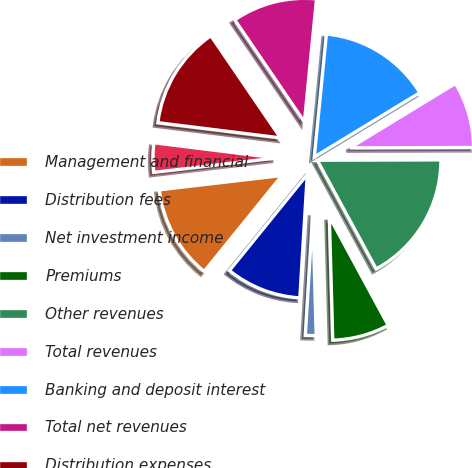Convert chart. <chart><loc_0><loc_0><loc_500><loc_500><pie_chart><fcel>Management and financial<fcel>Distribution fees<fcel>Net investment income<fcel>Premiums<fcel>Other revenues<fcel>Total revenues<fcel>Banking and deposit interest<fcel>Total net revenues<fcel>Distribution expenses<fcel>Interest credited to fixed<nl><fcel>12.3%<fcel>9.88%<fcel>1.4%<fcel>7.46%<fcel>17.14%<fcel>8.67%<fcel>14.72%<fcel>11.09%<fcel>13.51%<fcel>3.82%<nl></chart> 